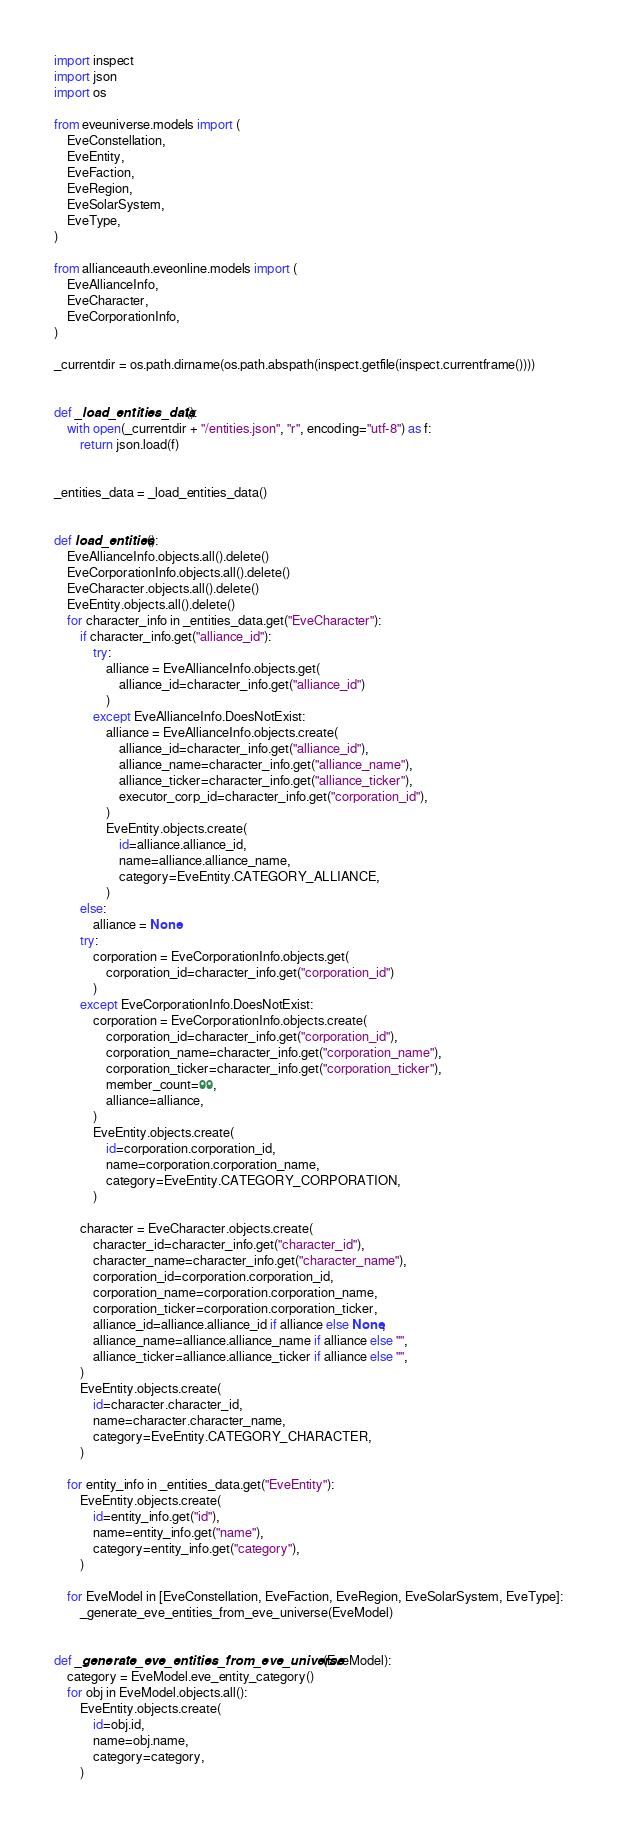<code> <loc_0><loc_0><loc_500><loc_500><_Python_>import inspect
import json
import os

from eveuniverse.models import (
    EveConstellation,
    EveEntity,
    EveFaction,
    EveRegion,
    EveSolarSystem,
    EveType,
)

from allianceauth.eveonline.models import (
    EveAllianceInfo,
    EveCharacter,
    EveCorporationInfo,
)

_currentdir = os.path.dirname(os.path.abspath(inspect.getfile(inspect.currentframe())))


def _load_entities_data():
    with open(_currentdir + "/entities.json", "r", encoding="utf-8") as f:
        return json.load(f)


_entities_data = _load_entities_data()


def load_entities():
    EveAllianceInfo.objects.all().delete()
    EveCorporationInfo.objects.all().delete()
    EveCharacter.objects.all().delete()
    EveEntity.objects.all().delete()
    for character_info in _entities_data.get("EveCharacter"):
        if character_info.get("alliance_id"):
            try:
                alliance = EveAllianceInfo.objects.get(
                    alliance_id=character_info.get("alliance_id")
                )
            except EveAllianceInfo.DoesNotExist:
                alliance = EveAllianceInfo.objects.create(
                    alliance_id=character_info.get("alliance_id"),
                    alliance_name=character_info.get("alliance_name"),
                    alliance_ticker=character_info.get("alliance_ticker"),
                    executor_corp_id=character_info.get("corporation_id"),
                )
                EveEntity.objects.create(
                    id=alliance.alliance_id,
                    name=alliance.alliance_name,
                    category=EveEntity.CATEGORY_ALLIANCE,
                )
        else:
            alliance = None
        try:
            corporation = EveCorporationInfo.objects.get(
                corporation_id=character_info.get("corporation_id")
            )
        except EveCorporationInfo.DoesNotExist:
            corporation = EveCorporationInfo.objects.create(
                corporation_id=character_info.get("corporation_id"),
                corporation_name=character_info.get("corporation_name"),
                corporation_ticker=character_info.get("corporation_ticker"),
                member_count=99,
                alliance=alliance,
            )
            EveEntity.objects.create(
                id=corporation.corporation_id,
                name=corporation.corporation_name,
                category=EveEntity.CATEGORY_CORPORATION,
            )

        character = EveCharacter.objects.create(
            character_id=character_info.get("character_id"),
            character_name=character_info.get("character_name"),
            corporation_id=corporation.corporation_id,
            corporation_name=corporation.corporation_name,
            corporation_ticker=corporation.corporation_ticker,
            alliance_id=alliance.alliance_id if alliance else None,
            alliance_name=alliance.alliance_name if alliance else "",
            alliance_ticker=alliance.alliance_ticker if alliance else "",
        )
        EveEntity.objects.create(
            id=character.character_id,
            name=character.character_name,
            category=EveEntity.CATEGORY_CHARACTER,
        )

    for entity_info in _entities_data.get("EveEntity"):
        EveEntity.objects.create(
            id=entity_info.get("id"),
            name=entity_info.get("name"),
            category=entity_info.get("category"),
        )

    for EveModel in [EveConstellation, EveFaction, EveRegion, EveSolarSystem, EveType]:
        _generate_eve_entities_from_eve_universe(EveModel)


def _generate_eve_entities_from_eve_universe(EveModel):
    category = EveModel.eve_entity_category()
    for obj in EveModel.objects.all():
        EveEntity.objects.create(
            id=obj.id,
            name=obj.name,
            category=category,
        )
</code> 